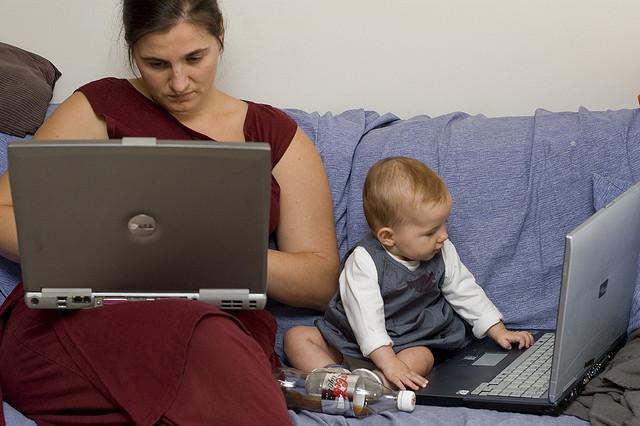What is laying on top of the boy?
Write a very short answer. Nothing. How many computers?
Short answer required. 2. What kind of laptop computer does the girl have?
Concise answer only. Dell. What color is the woman's dress?
Answer briefly. Red. What kind of bottle is on the couch?
Answer briefly. Plastic. How many laptops are there?
Write a very short answer. 2. 